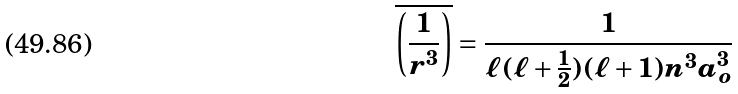Convert formula to latex. <formula><loc_0><loc_0><loc_500><loc_500>\overline { \left ( \frac { 1 } { r ^ { 3 } } \right ) } = \frac { 1 } { \ell ( \ell + \frac { 1 } { 2 } ) ( \ell + 1 ) n ^ { 3 } a _ { o } ^ { 3 } }</formula> 